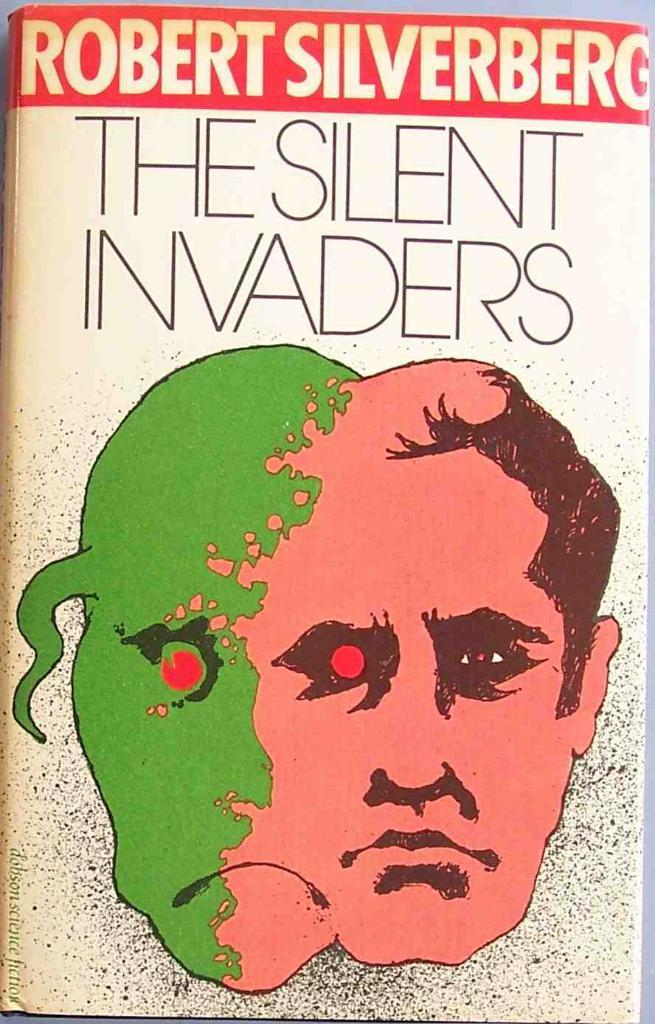What object can be seen in the image that is typically used for reading or learning? There is a book in the image that is typically used for reading or learning. What can be found on the book in the image? There is text on the book in the image. What type of artwork is present in the image? There is a painting of a human face in the image. How many planes are visible in the image? There are no planes visible in the image. What type of dress is the person wearing in the image? There is no person or dress present in the image; it only features a book and a painting of a human face. 